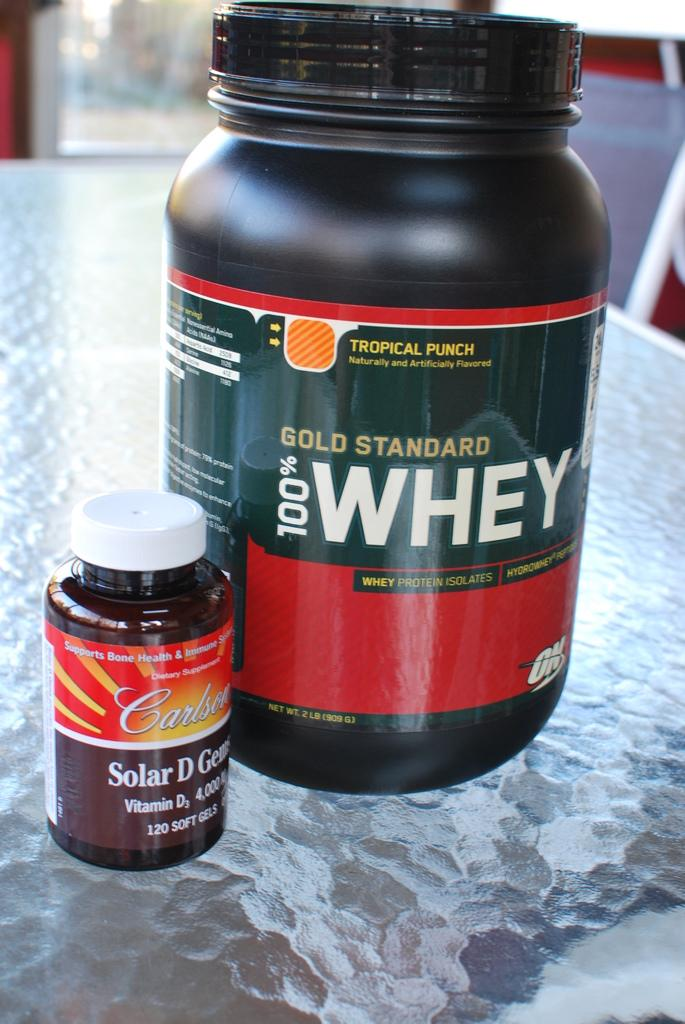<image>
Describe the image concisely. A canister of 100% Whey protein powder stands next to small bottle of pills 